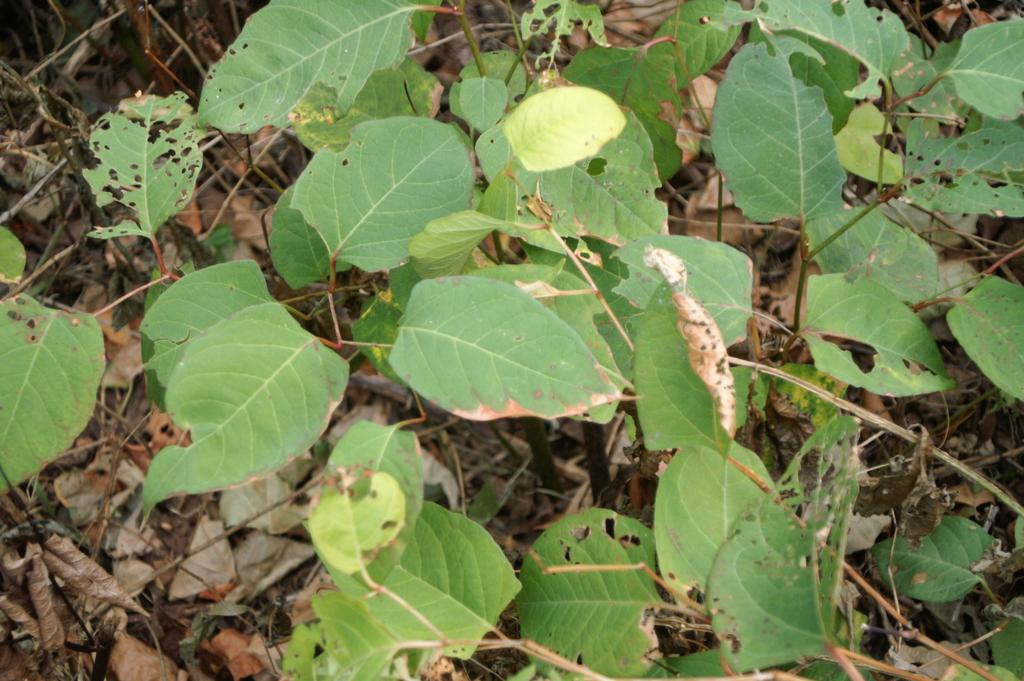What type of natural material can be seen in the image? There are dry leaves in the image. What type of living organisms are present in the image? There are plants in the image. How many balls can be seen in the image? There are no balls present in the image. What type of hydrant is visible in the image? There is no hydrant present in the image. 